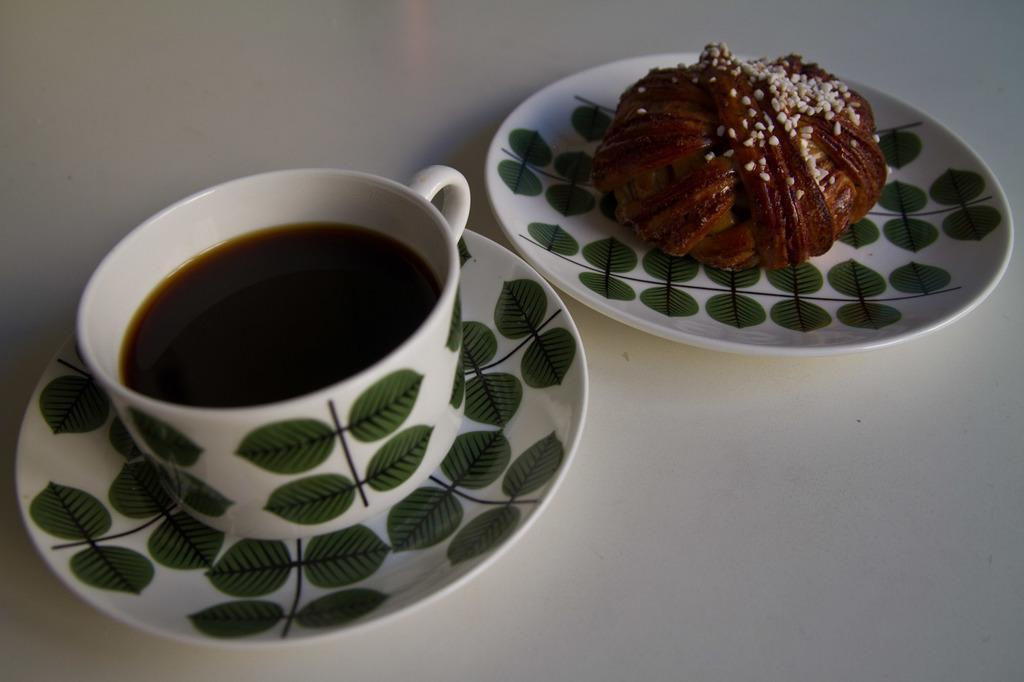Can you describe this image briefly? In this image, I can see a cup and saucer and the plate. This cup contains some liquid and the plate contains food item. I think this is the table, which is white in color. 